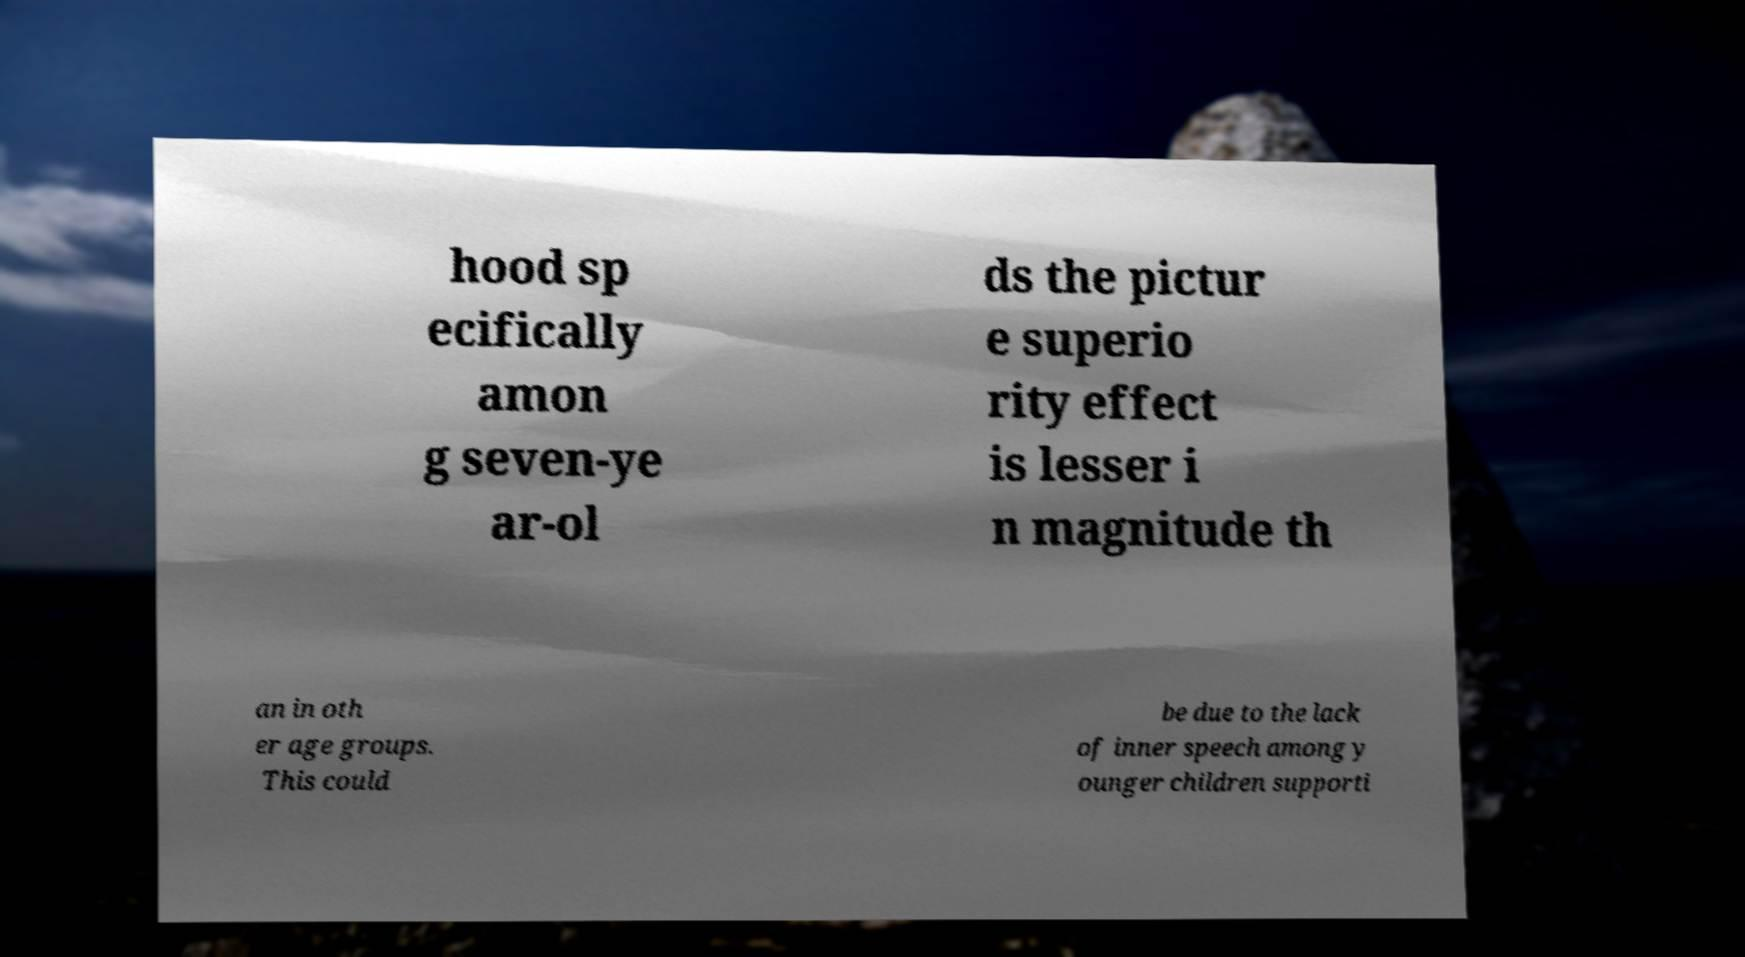Can you accurately transcribe the text from the provided image for me? hood sp ecifically amon g seven-ye ar-ol ds the pictur e superio rity effect is lesser i n magnitude th an in oth er age groups. This could be due to the lack of inner speech among y ounger children supporti 